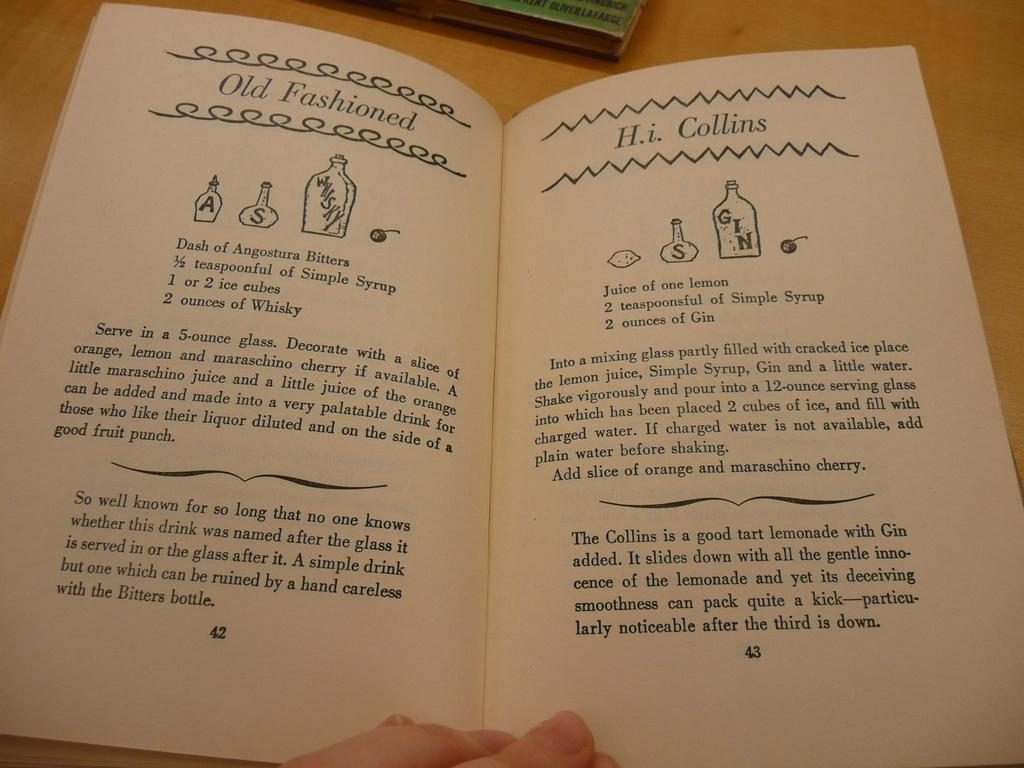Provide a one-sentence caption for the provided image. A recipe book is opened to page 42, which has the recipe for an Old Fashioned and page 43 with a recipe for H.i. Collins. 